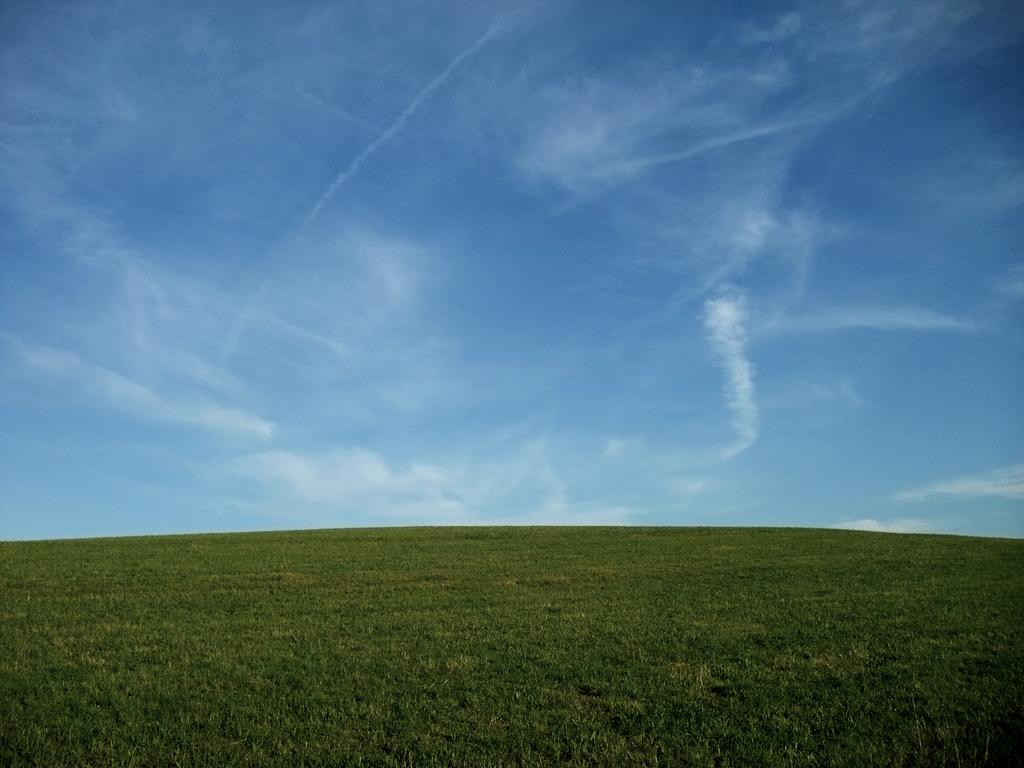What type of vegetation is present in the image? There is grass in the image. What is visible at the top of the image? The sky is visible at the top of the image. What can be seen in the sky? There are clouds in the sky. Where is the cork located in the image? There is no cork present in the image. What type of drawer can be seen in the image? There is no drawer present in the image. 